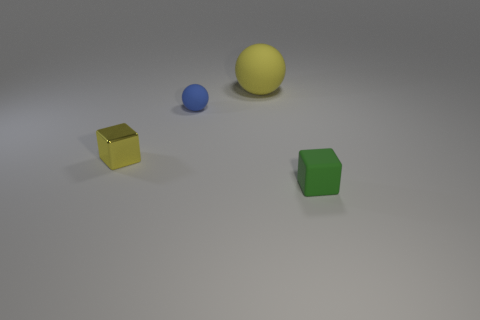Are the small ball that is on the left side of the green thing and the big sphere made of the same material?
Offer a very short reply. Yes. Is the number of cubes that are behind the green block the same as the number of blue matte spheres that are behind the small blue ball?
Your answer should be compact. No. There is a yellow object behind the block on the left side of the small blue sphere; what is its size?
Ensure brevity in your answer.  Large. There is a small thing that is left of the green thing and in front of the blue matte ball; what material is it made of?
Your answer should be very brief. Metal. What number of other objects are there of the same size as the blue object?
Your answer should be very brief. 2. What is the color of the tiny matte ball?
Provide a short and direct response. Blue. There is a matte object that is behind the blue rubber thing; is it the same color as the tiny shiny object in front of the large object?
Keep it short and to the point. Yes. What size is the yellow matte thing?
Your response must be concise. Large. There is a rubber thing behind the blue rubber ball; how big is it?
Your answer should be very brief. Large. There is a matte object that is behind the green matte block and in front of the big sphere; what is its shape?
Your answer should be very brief. Sphere. 